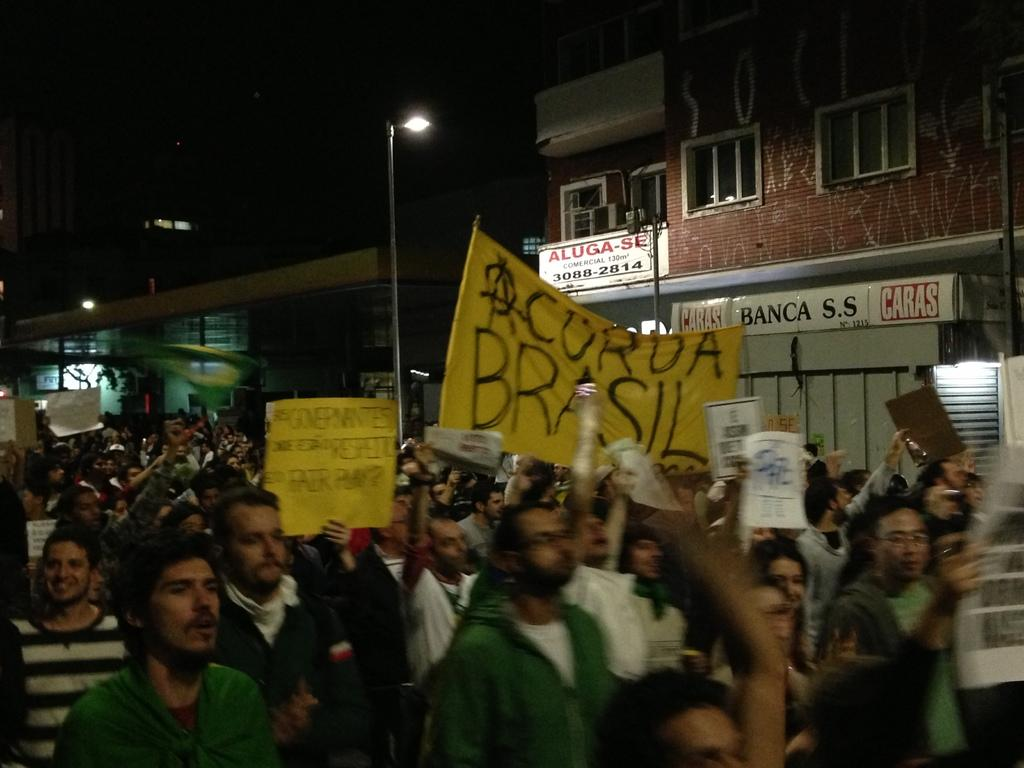How many people are in the group depicted in the image? There is a group of people in the image, but the exact number is not specified. What are some of the people in the group doing? Some people in the group are walking, while others are holding banners and boards. What can be seen in the background of the image? There are light poles, buildings, and windows visible in the background of the image. Where is the cemetery located in the image? There is no cemetery present in the image. What type of root can be seen growing on the banners in the image? There are no roots visible in the image, and the banners are not described as having any roots. 